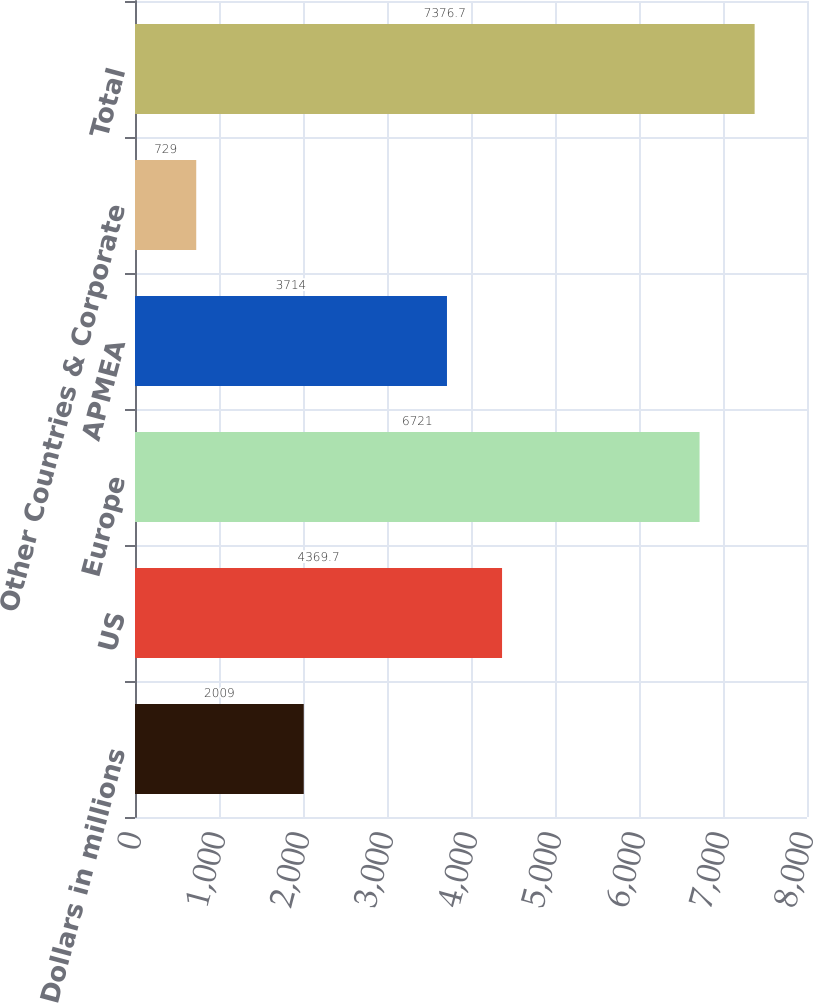Convert chart. <chart><loc_0><loc_0><loc_500><loc_500><bar_chart><fcel>Dollars in millions<fcel>US<fcel>Europe<fcel>APMEA<fcel>Other Countries & Corporate<fcel>Total<nl><fcel>2009<fcel>4369.7<fcel>6721<fcel>3714<fcel>729<fcel>7376.7<nl></chart> 